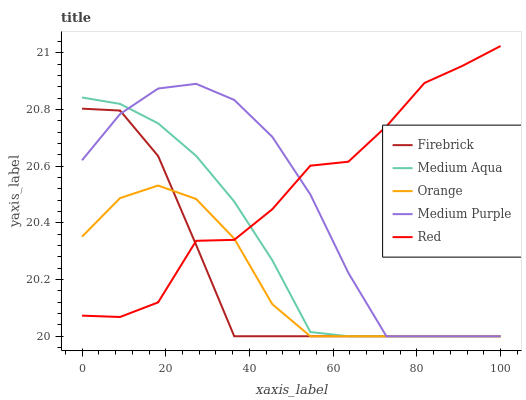Does Orange have the minimum area under the curve?
Answer yes or no. Yes. Does Red have the maximum area under the curve?
Answer yes or no. Yes. Does Medium Purple have the minimum area under the curve?
Answer yes or no. No. Does Medium Purple have the maximum area under the curve?
Answer yes or no. No. Is Medium Aqua the smoothest?
Answer yes or no. Yes. Is Red the roughest?
Answer yes or no. Yes. Is Medium Purple the smoothest?
Answer yes or no. No. Is Medium Purple the roughest?
Answer yes or no. No. Does Orange have the lowest value?
Answer yes or no. Yes. Does Red have the lowest value?
Answer yes or no. No. Does Red have the highest value?
Answer yes or no. Yes. Does Medium Purple have the highest value?
Answer yes or no. No. Does Firebrick intersect Orange?
Answer yes or no. Yes. Is Firebrick less than Orange?
Answer yes or no. No. Is Firebrick greater than Orange?
Answer yes or no. No. 